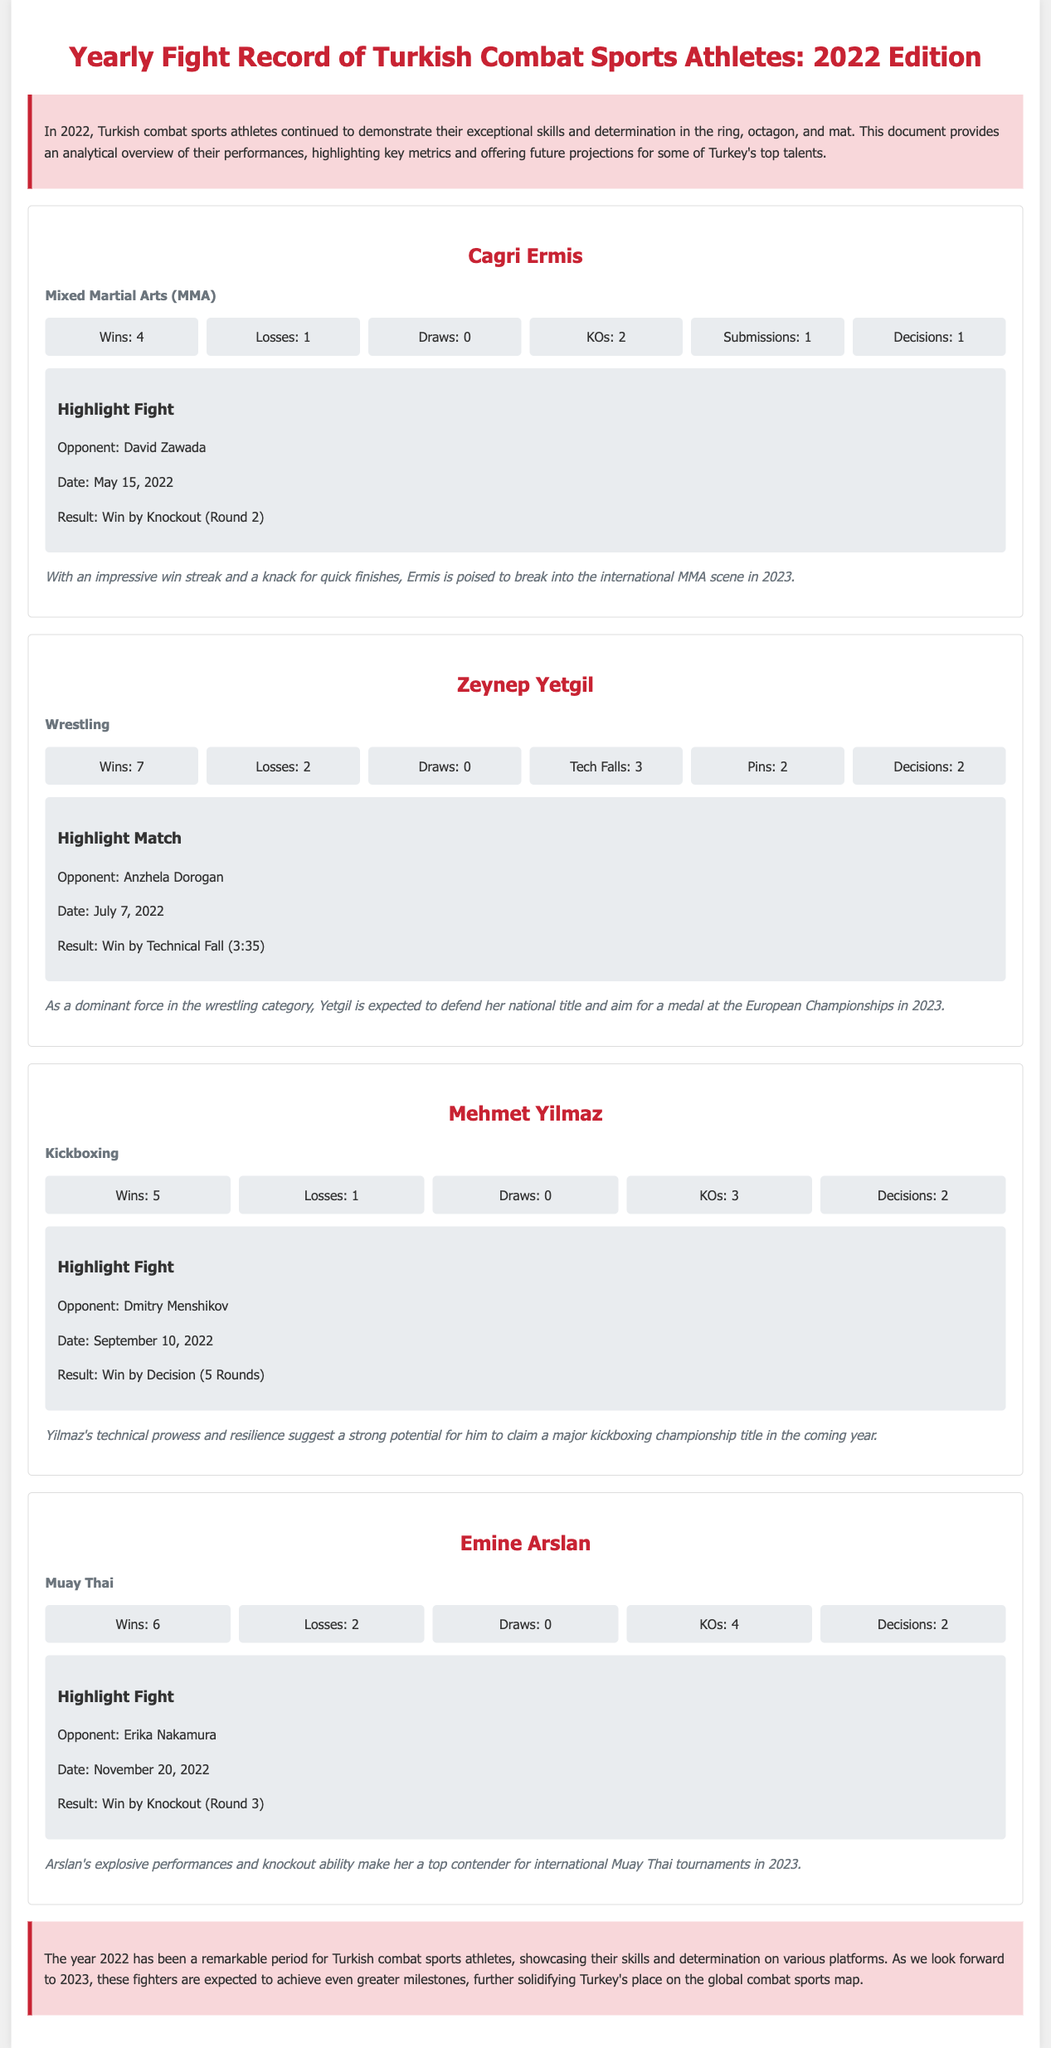what is the title of the document? The title of the document is mentioned in the header section, summarizing its content on Turkish combat sports athletes in 2022.
Answer: Yearly Fight Record of Turkish Combat Sports Athletes: 2022 Edition how many victories did Cagri Ermis achieve in 2022? The number of victories for Cagri Ermis is provided in his athlete card, indicating his overall performance in that year.
Answer: 4 what was the outcome of Zeynep Yetgil's highlight match? The outcome is noted in her athlete card, which states the result of her significant match in detail.
Answer: Win by Technical Fall (3:35) which sport does Emine Arslan compete in? This detail is found in her athlete card, which specifies her sport category for 2022.
Answer: Muay Thai how many losses did Mehmet Yilmaz incur in 2022? The number of losses is explicitly listed in his performance metrics within the athlete card.
Answer: 1 who did Cagri Ermis fight on May 15, 2022? The opponent's name is directly stated in the highlight fight section of his athlete card.
Answer: David Zawada what can be expected from Zeynep Yetgil in 2023? The future projection section provides insights into her anticipated accomplishments in the upcoming year.
Answer: Defend her national title and aim for a medal at the European Championships how many total wins did Emine Arslan have in 2022? The total number of wins is indicated in her performance metrics shown in the athlete card.
Answer: 6 